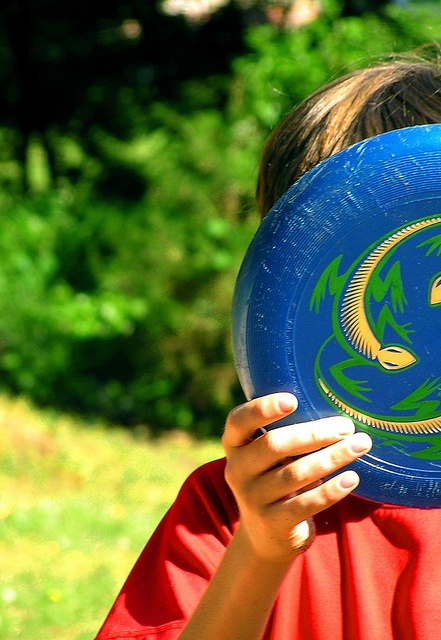Describe the objects in this image and their specific colors. I can see people in black, red, salmon, and maroon tones and frisbee in black, blue, navy, teal, and green tones in this image. 